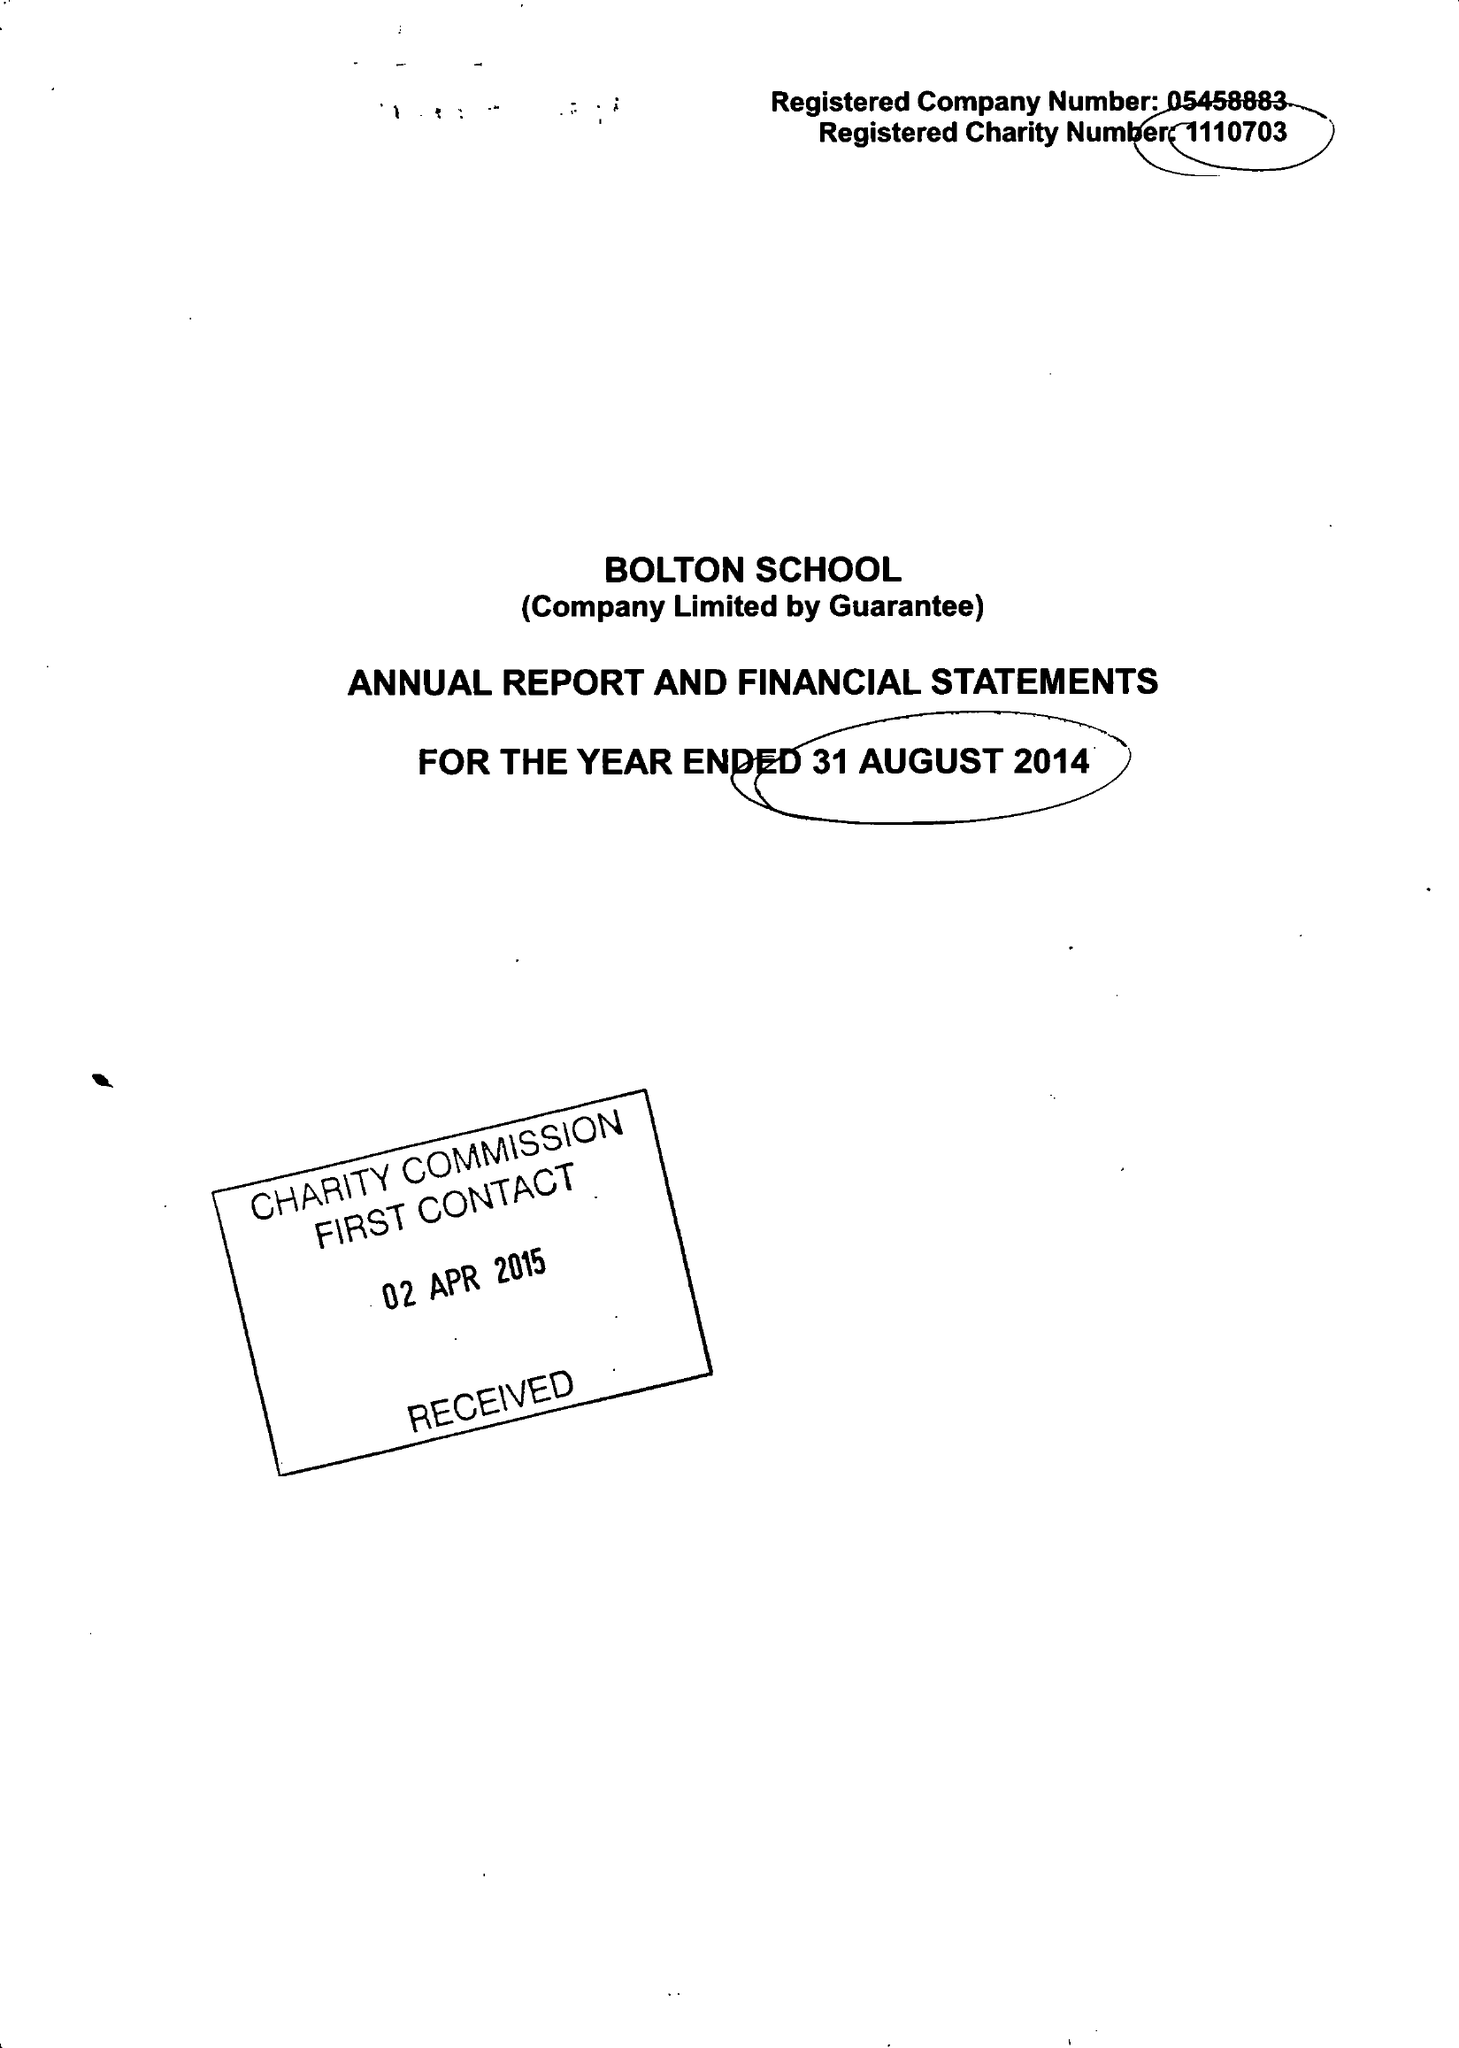What is the value for the income_annually_in_british_pounds?
Answer the question using a single word or phrase. 27112000.00 